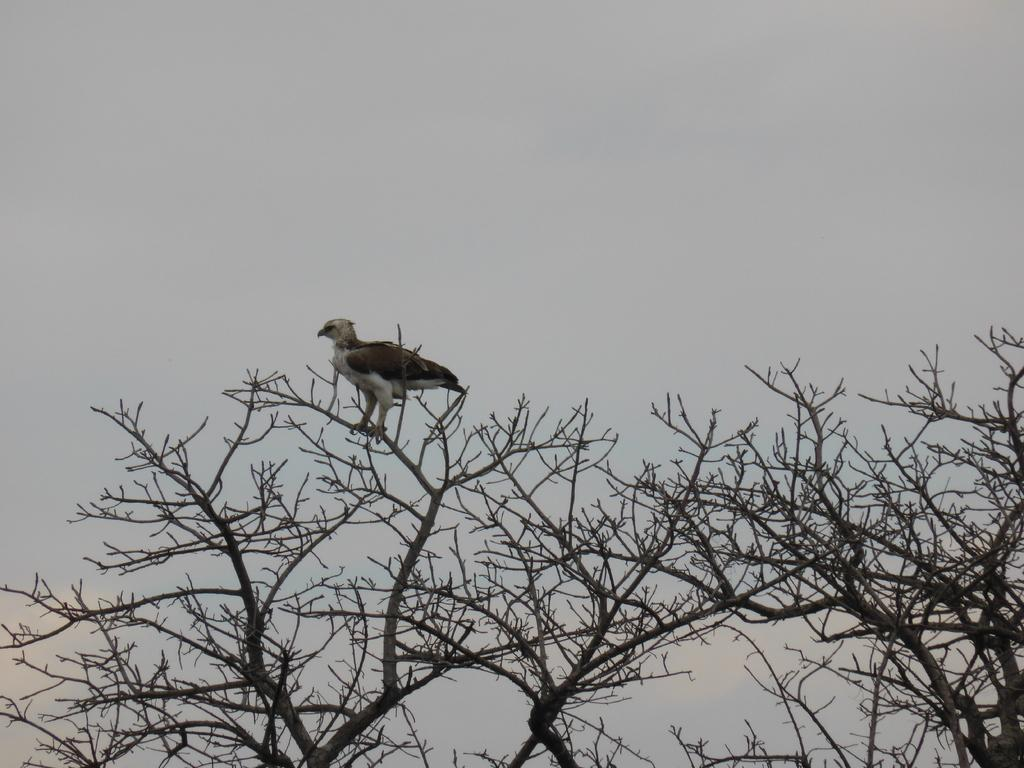What type of animal is in the image? There is a bird in the image. Where is the bird located? The bird is on a dried tree. What can be seen in the background of the image? The sky is visible in the background of the image. What colors are present in the sky? The sky has blue and white colors. How many bricks are visible in the image? There are no bricks present in the image. 